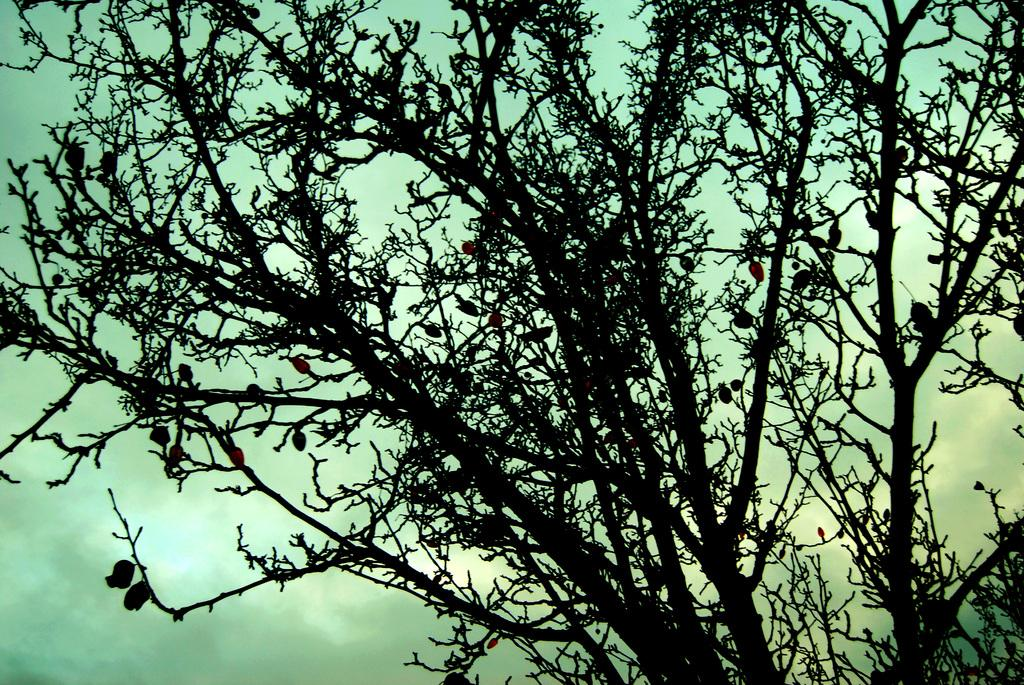What is the main subject in the center of the image? There is a tree in the center of the image. What can be seen in the background of the image? There are clouds and the sky visible in the background of the image. What type of waste can be seen on the tree in the image? There is no waste present on the tree in the image. What organization is responsible for maintaining the tree in the image? There is no information about any organization responsible for maintaining the tree in the image. 